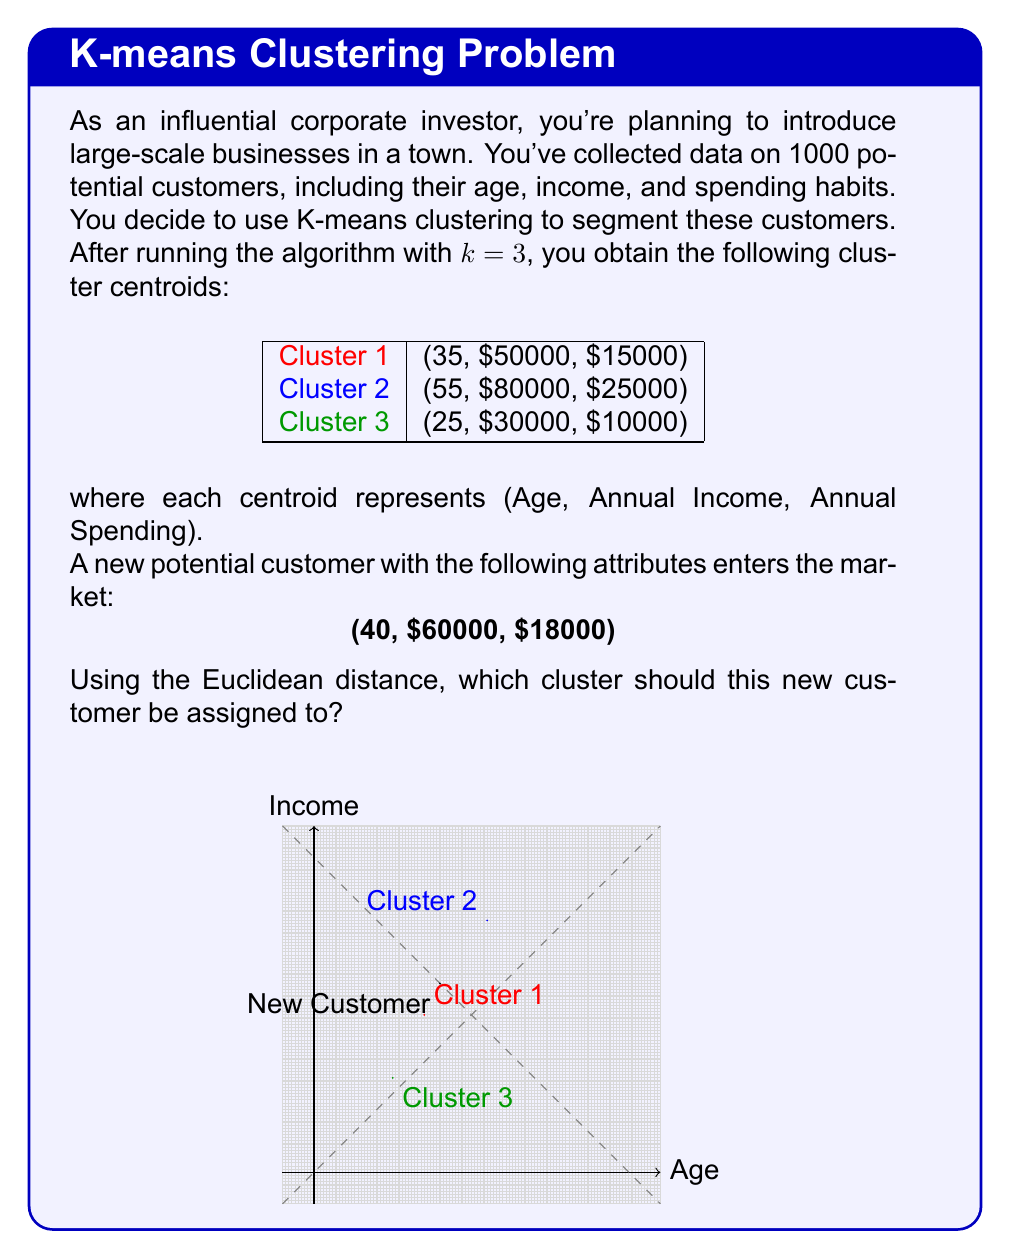Could you help me with this problem? To determine which cluster the new customer should be assigned to, we need to calculate the Euclidean distance between the new customer and each cluster centroid, then assign the customer to the cluster with the smallest distance.

The Euclidean distance in 3D space is given by:

$$d = \sqrt{(x_2-x_1)^2 + (y_2-y_1)^2 + (z_2-z_1)^2}$$

Let's calculate the distance to each cluster:

1. Distance to Cluster 1:
   $$d_1 = \sqrt{(40-35)^2 + (60000-50000)^2 + (18000-15000)^2}$$
   $$d_1 = \sqrt{25 + 100000000 + 9000000} = \sqrt{109000025} \approx 10440.31$$

2. Distance to Cluster 2:
   $$d_2 = \sqrt{(40-55)^2 + (60000-80000)^2 + (18000-25000)^2}$$
   $$d_2 = \sqrt{225 + 400000000 + 49000000} = \sqrt{449000225} \approx 21189.72$$

3. Distance to Cluster 3:
   $$d_3 = \sqrt{(40-25)^2 + (60000-30000)^2 + (18000-10000)^2}$$
   $$d_3 = \sqrt{225 + 900000000 + 64000000} = \sqrt{964000225} \approx 31048.03$$

The smallest distance is $d_1$, which corresponds to Cluster 1.
Answer: Cluster 1 